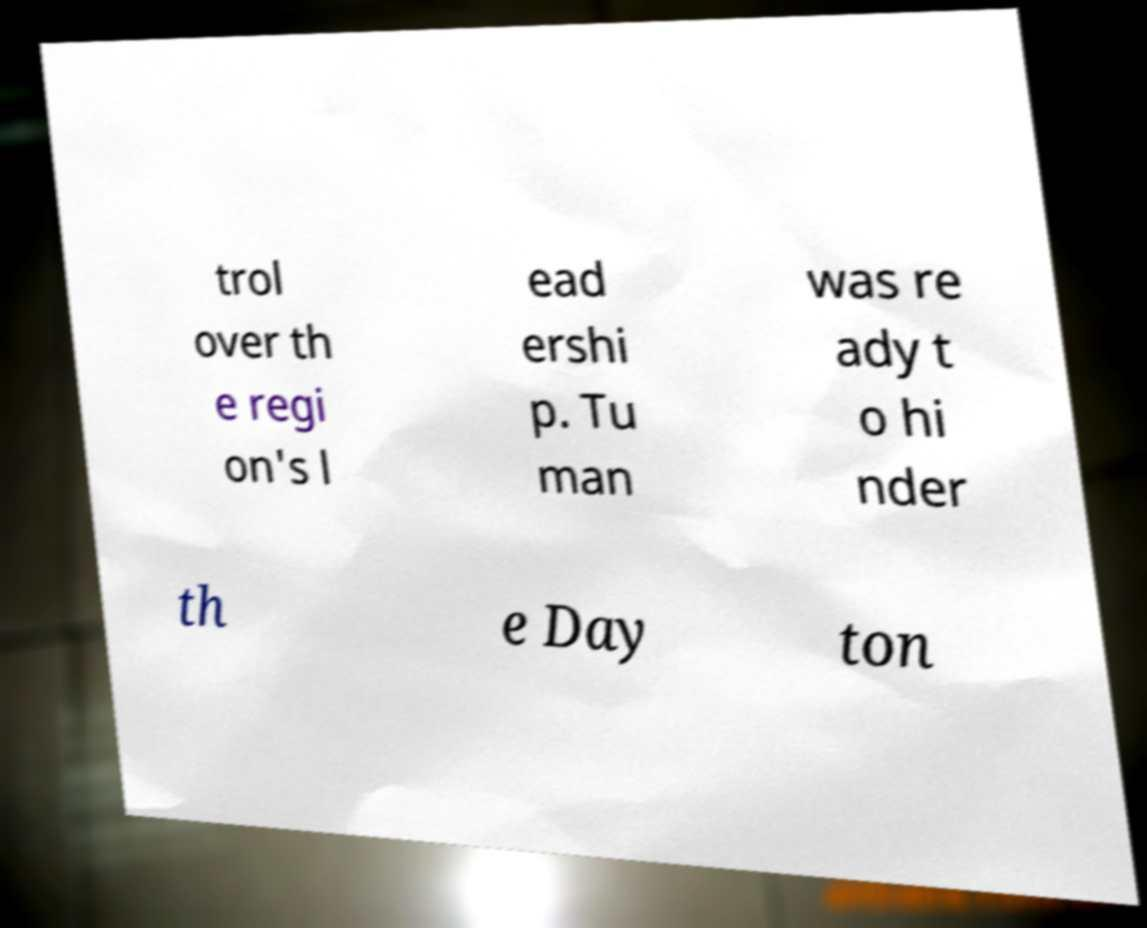Can you accurately transcribe the text from the provided image for me? trol over th e regi on's l ead ershi p. Tu man was re ady t o hi nder th e Day ton 